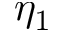<formula> <loc_0><loc_0><loc_500><loc_500>\eta _ { 1 }</formula> 